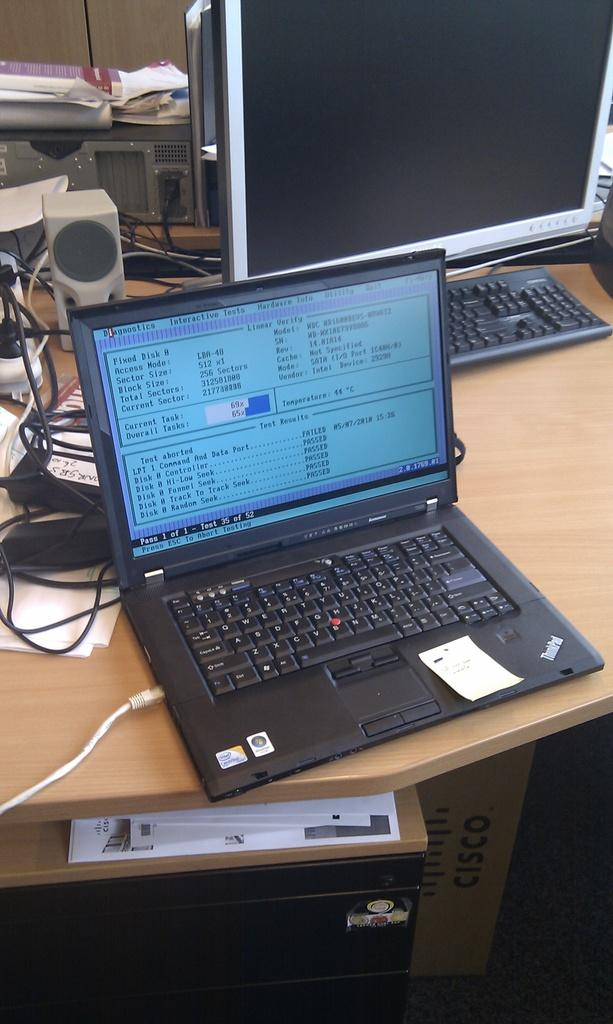<image>
Create a compact narrative representing the image presented. a lap top computer open to a screen for "test results" reading Passed 